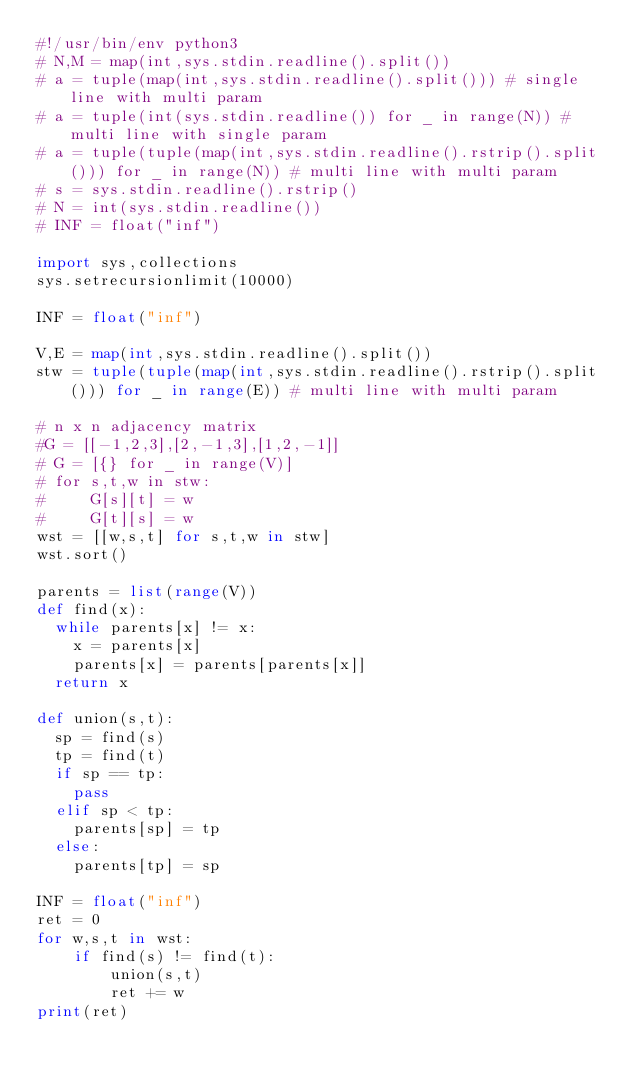Convert code to text. <code><loc_0><loc_0><loc_500><loc_500><_Python_>#!/usr/bin/env python3
# N,M = map(int,sys.stdin.readline().split())
# a = tuple(map(int,sys.stdin.readline().split())) # single line with multi param
# a = tuple(int(sys.stdin.readline()) for _ in range(N)) # multi line with single param
# a = tuple(tuple(map(int,sys.stdin.readline().rstrip().split())) for _ in range(N)) # multi line with multi param
# s = sys.stdin.readline().rstrip()
# N = int(sys.stdin.readline())
# INF = float("inf")

import sys,collections
sys.setrecursionlimit(10000)

INF = float("inf")

V,E = map(int,sys.stdin.readline().split())
stw = tuple(tuple(map(int,sys.stdin.readline().rstrip().split())) for _ in range(E)) # multi line with multi param

# n x n adjacency matrix
#G = [[-1,2,3],[2,-1,3],[1,2,-1]]
# G = [{} for _ in range(V)]
# for s,t,w in stw:
#     G[s][t] = w
#     G[t][s] = w
wst = [[w,s,t] for s,t,w in stw]
wst.sort()

parents = list(range(V))
def find(x):
  while parents[x] != x:
    x = parents[x]
    parents[x] = parents[parents[x]]
  return x

def union(s,t):
  sp = find(s)
  tp = find(t)
  if sp == tp:
    pass
  elif sp < tp:
    parents[sp] = tp
  else:
    parents[tp] = sp

INF = float("inf")
ret = 0
for w,s,t in wst:
    if find(s) != find(t):
        union(s,t)
        ret += w
print(ret)
</code> 